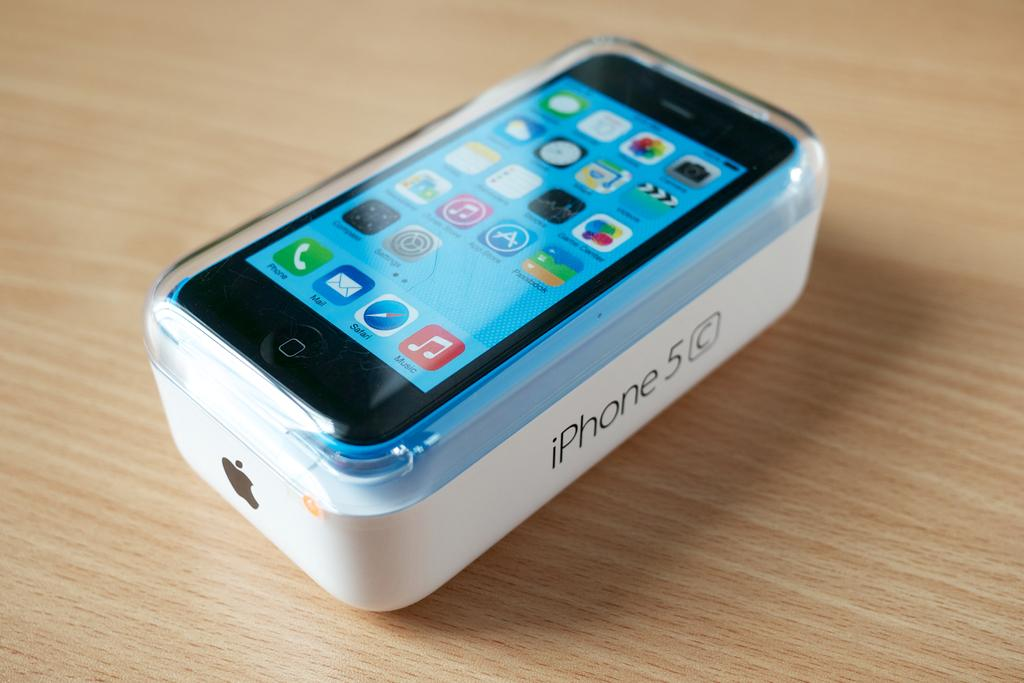Provide a one-sentence caption for the provided image. A new Iphone in a case is sitting on an Iphone box labeled iphone 5c. 